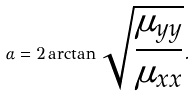<formula> <loc_0><loc_0><loc_500><loc_500>\alpha = 2 \arctan \sqrt { \frac { \mu _ { y y } } { \mu _ { x x } } } .</formula> 